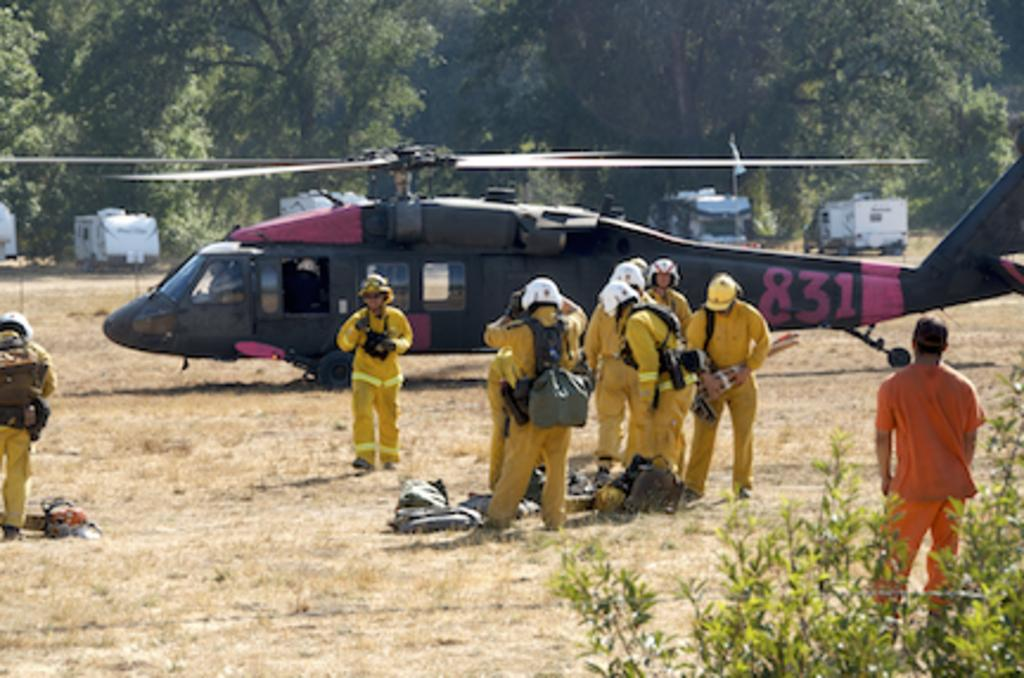<image>
Share a concise interpretation of the image provided. People are gathered in front of a helicopter with 831 painted on its tail. 